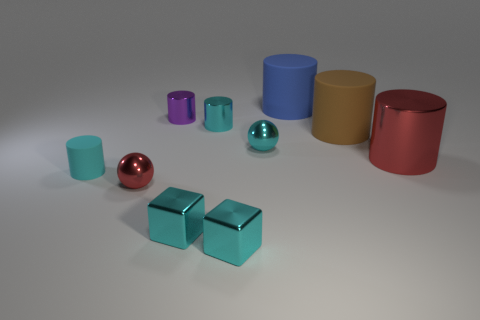There is a object that is the same color as the big metal cylinder; what shape is it?
Make the answer very short. Sphere. What is the size of the metal ball that is the same color as the large metal cylinder?
Your response must be concise. Small. There is another brown thing that is the same shape as the big shiny object; what is its size?
Offer a very short reply. Large. What color is the other large matte thing that is the same shape as the brown object?
Your answer should be compact. Blue. What number of tiny objects are the same color as the small matte cylinder?
Your answer should be compact. 4. There is a small thing that is behind the small cyan cylinder behind the brown rubber cylinder; what is its material?
Offer a terse response. Metal. How big is the ball behind the red shiny object behind the red thing on the left side of the cyan ball?
Give a very brief answer. Small. There is a tiny purple object; is it the same shape as the red thing that is in front of the tiny matte thing?
Provide a succinct answer. No. What is the material of the big red thing?
Ensure brevity in your answer.  Metal. How many metallic things are tiny cubes or large red cylinders?
Offer a very short reply. 3. 